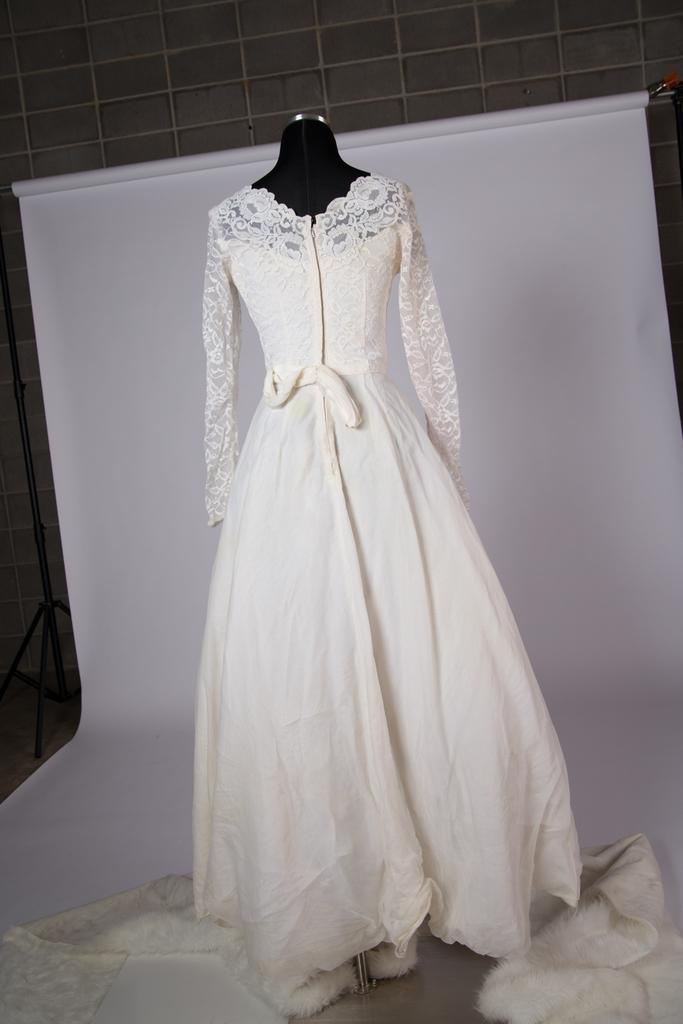What is the main subject of the image? There is a mannequin in the image. What is the mannequin wearing? The mannequin is wearing a white dress. What can be seen in the background of the image? There is a wall in the background of the image. What color is the object placed behind the mannequin? There is a white color object placed behind the mannequin. How does the mannequin attract attention during the earthquake in the image? There is no earthquake present in the image, and the mannequin does not attract attention as it is an inanimate object. 